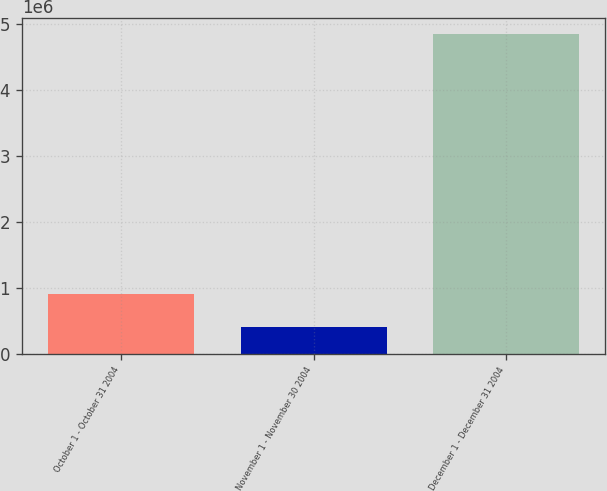Convert chart to OTSL. <chart><loc_0><loc_0><loc_500><loc_500><bar_chart><fcel>October 1 - October 31 2004<fcel>November 1 - November 30 2004<fcel>December 1 - December 31 2004<nl><fcel>907300<fcel>397100<fcel>4.8471e+06<nl></chart> 